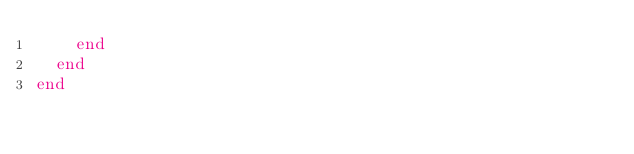<code> <loc_0><loc_0><loc_500><loc_500><_Ruby_>    end
  end
end
</code> 